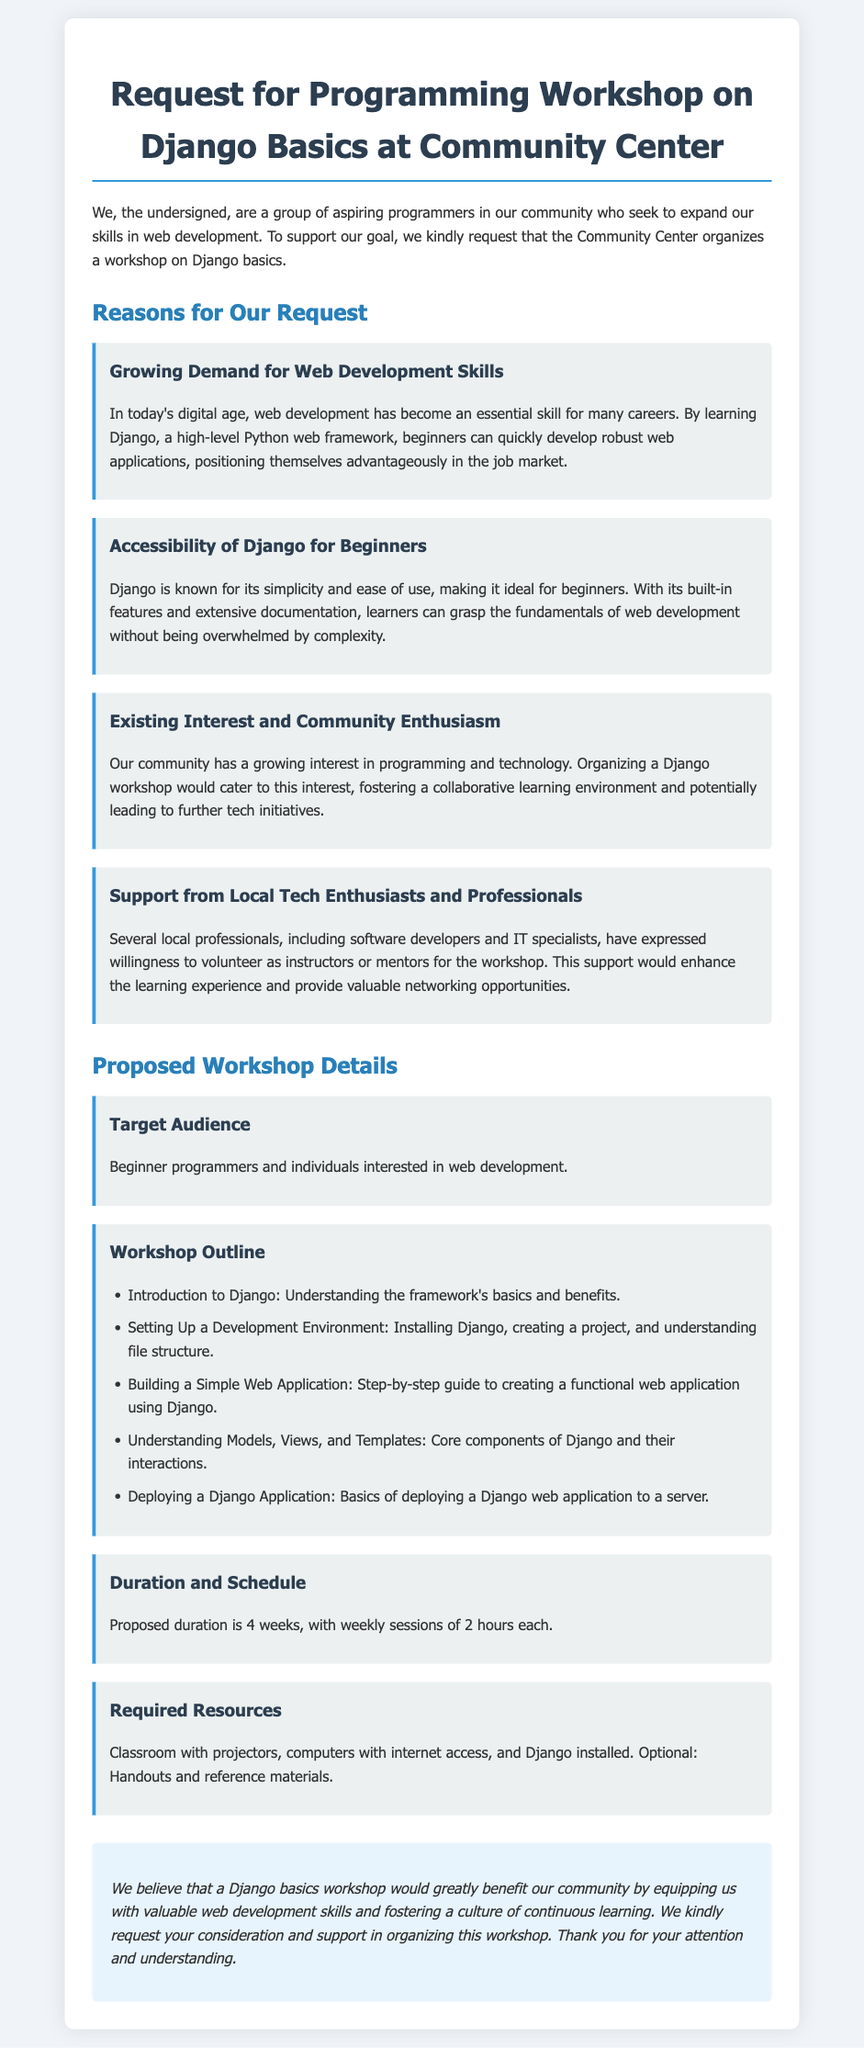What is the title of the petition? The title of the petition is the header found at the top of the document, highlighting the request being made.
Answer: Request for Programming Workshop on Django Basics at Community Center What is one reason for the request? The document lists several reasons for the request, and this question aims to identify one of them stated in the Reasons for Our Request section.
Answer: Growing Demand for Web Development Skills Who are potential instructors for the workshop? The document mentions the support from local professionals and their willingness to help with the workshop, which implies the potential instructors.
Answer: Local professionals, including software developers and IT specialists What is the proposed duration of the workshop? The proposed duration is stated clearly in the Proposed Workshop Details section of the document, giving insight into how long the workshop will last.
Answer: 4 weeks What is the target audience for the workshop? The Target Audience section specifies who the workshop is aimed at, indicating the intended participants.
Answer: Beginner programmers and individuals interested in web development How many sessions are proposed? The document provides information about the frequency of sessions as part of the workshop outline, which is crucial for attendance planning.
Answer: Weekly sessions What is one resource required for the workshop? In the Required Resources section, a classroom setup is mentioned, indicating one of the necessities for conducting the workshop.
Answer: Classroom with projectors What is the main goal of the petition? The overall purpose of the document is to request an event that benefits the community, summarized at the conclusion of the petition.
Answer: Organizing a workshop on Django basics How long is each session proposed to last? The document specifies the length of each session in the Duration and Schedule section, which indicates the format of the workshop.
Answer: 2 hours 